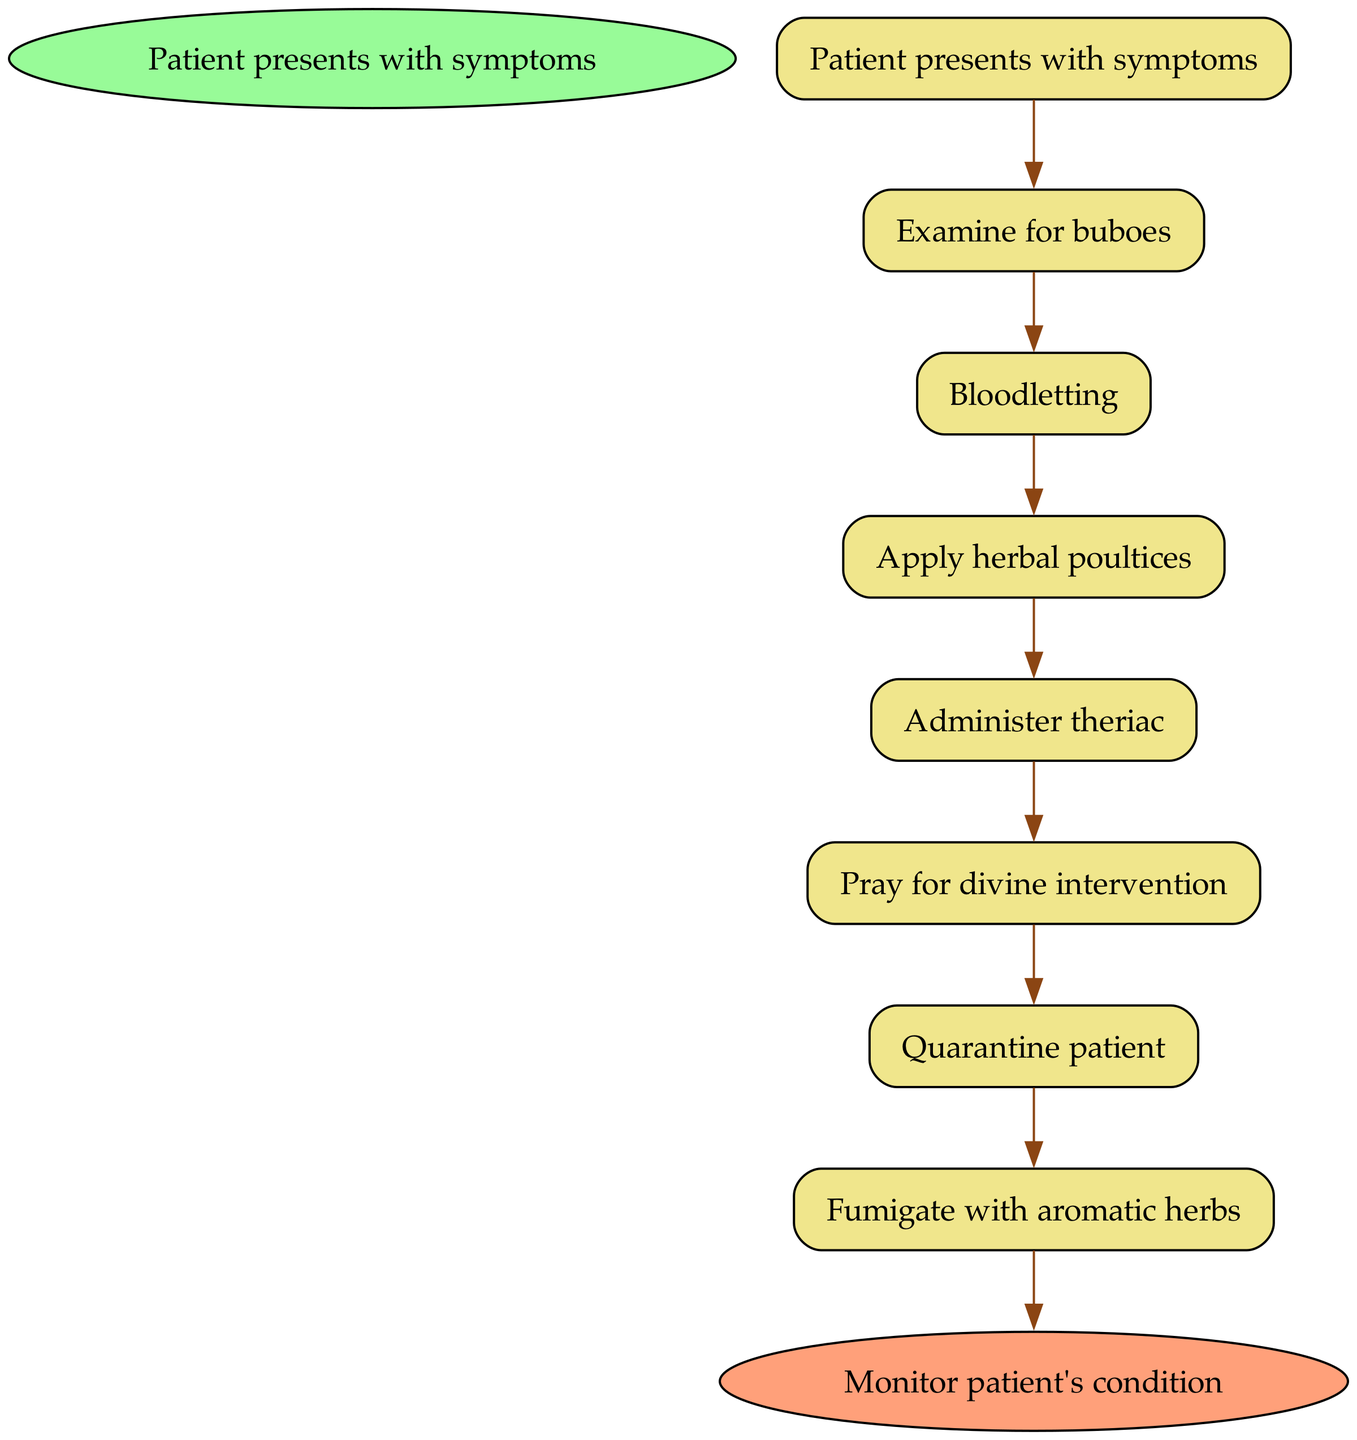What is the starting point of the treatment pathway? The starting point of the treatment pathway is "Patient presents with symptoms." This is identified as the first node in the diagram, which indicates the beginning of the clinical pathway for treating bubonic plague.
Answer: Patient presents with symptoms What follows after examining for buboes? After "Examine for buboes," the next step in the pathway is "Bloodletting." This is determined by tracing the directed edge from the first node to the next node as indicated in the diagram.
Answer: Bloodletting How many total nodes are present in the diagram? The diagram consists of a total of 8 nodes. This includes 1 start node, 6 treatment steps, and 1 end node, which can be counted directly by examining the nodes listed in the diagram.
Answer: 8 What is the final step indicated in the treatment pathway? The final step indicated in the treatment pathway is "Monitor patient's condition." This is the end node of the pathway where the overall patient status is evaluated after following the treatment steps.
Answer: Monitor patient's condition What action is taken immediately after administering theriac? The action taken immediately after administering theriac is "Pray for divine intervention." This is determined by the edge leading from "Administer theriac" to "Pray for divine intervention" in the diagram.
Answer: Pray for divine intervention What actions are taken after the patient is quarantined? After the patient is quarantined, the action taken is "Fumigate with aromatic herbs." This follows the edge from "Quarantine patient" leading to "Fumigate with aromatic herbs" indicating subsequent measures taken to combat the plague.
Answer: Fumigate with aromatic herbs What is the significance of the quarantine step in the treatment pathway? Quarantine is significant as it represents a crucial public health measure to prevent the spread of the disease to others. In the diagram, it follows the spiritual remedy of praying, indicating a shift towards isolation and protective measures for the community.
Answer: Prevent the spread How many treatment steps are there between the start and the end of the pathway? There are 6 treatment steps between the start and the end of the pathway. This can be counted by listing all nodes starting from "Examine for buboes" until reaching "Administer theriac," followed by the patient's condition monitoring node.
Answer: 6 